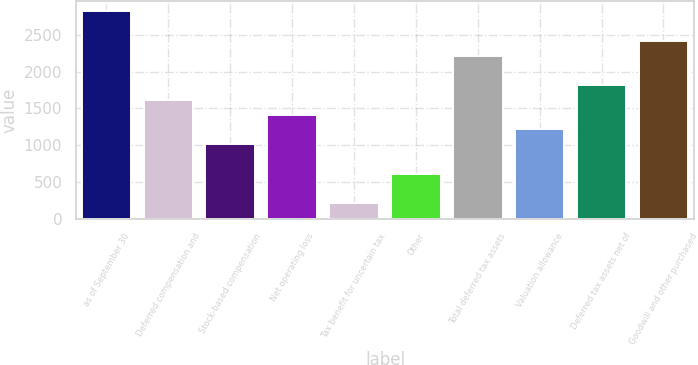Convert chart to OTSL. <chart><loc_0><loc_0><loc_500><loc_500><bar_chart><fcel>as of September 30<fcel>Deferred compensation and<fcel>Stock-based compensation<fcel>Net operating loss<fcel>Tax benefit for uncertain tax<fcel>Other<fcel>Total deferred tax assets<fcel>Valuation allowance<fcel>Deferred tax assets net of<fcel>Goodwill and other purchased<nl><fcel>2821.6<fcel>1616.2<fcel>1013.5<fcel>1415.3<fcel>209.9<fcel>611.7<fcel>2218.9<fcel>1214.4<fcel>1817.1<fcel>2419.8<nl></chart> 